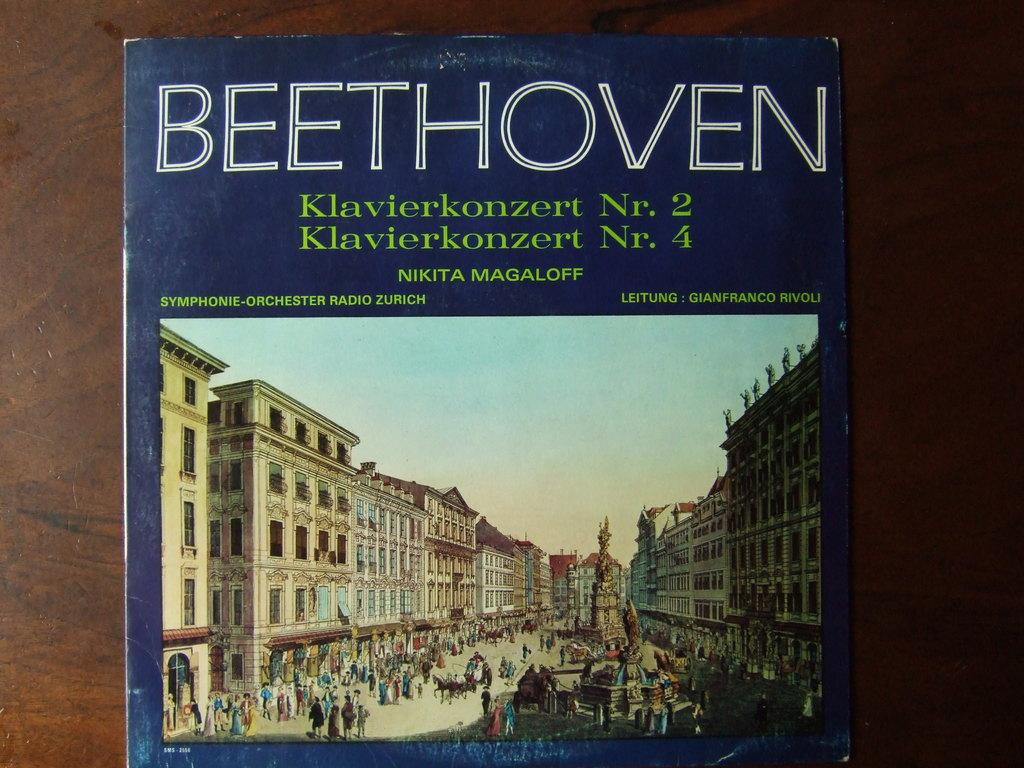<image>
Present a compact description of the photo's key features. The front cover of a book of Beethoven's work, specifically concertos number 2 and 4. 